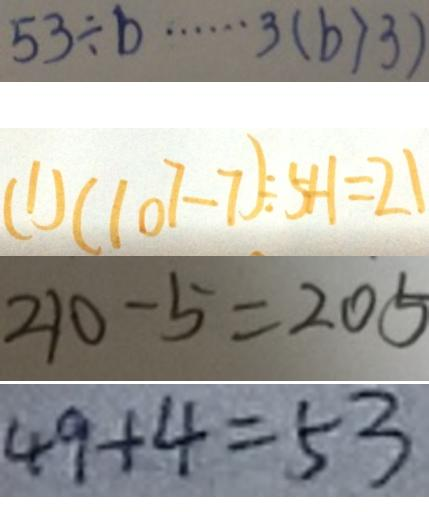Convert formula to latex. <formula><loc_0><loc_0><loc_500><loc_500>5 3 \div b \cdots 3 ( b > 3 ) 
 ( 1 ) ( 1 0 7 - 7 ) \div 5 + 1 = 2 1 
 2 1 0 - 5 = 2 0 5 
 4 9 + 4 = 5 3</formula> 